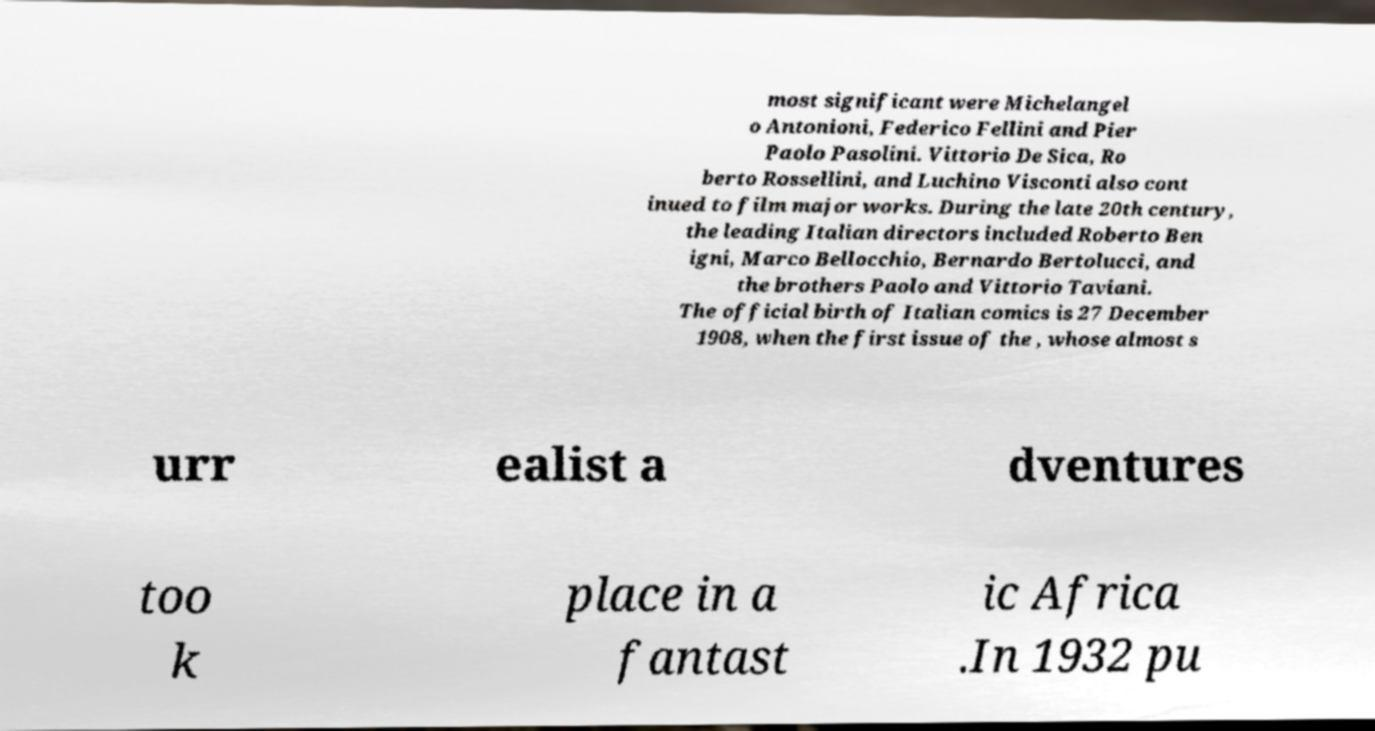Please identify and transcribe the text found in this image. most significant were Michelangel o Antonioni, Federico Fellini and Pier Paolo Pasolini. Vittorio De Sica, Ro berto Rossellini, and Luchino Visconti also cont inued to film major works. During the late 20th century, the leading Italian directors included Roberto Ben igni, Marco Bellocchio, Bernardo Bertolucci, and the brothers Paolo and Vittorio Taviani. The official birth of Italian comics is 27 December 1908, when the first issue of the , whose almost s urr ealist a dventures too k place in a fantast ic Africa .In 1932 pu 